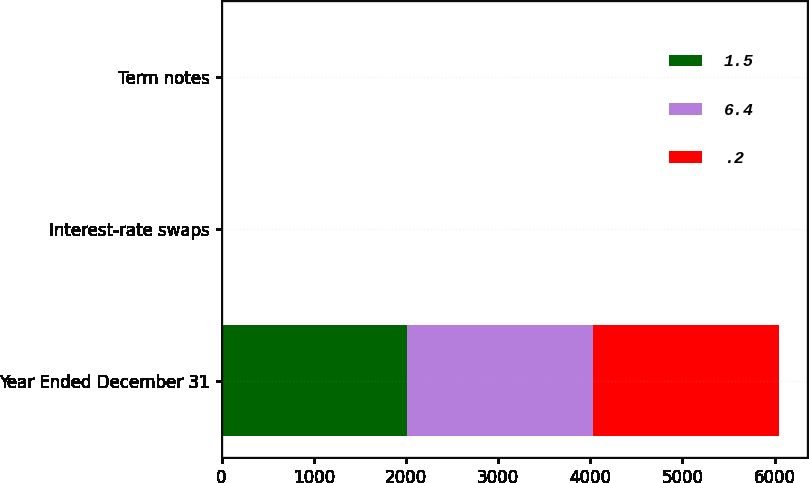<chart> <loc_0><loc_0><loc_500><loc_500><stacked_bar_chart><ecel><fcel>Year Ended December 31<fcel>Interest-rate swaps<fcel>Term notes<nl><fcel>1.5<fcel>2017<fcel>2.3<fcel>1.5<nl><fcel>6.4<fcel>2016<fcel>5.5<fcel>6.4<nl><fcel>0.2<fcel>2015<fcel>0.9<fcel>0.2<nl></chart> 